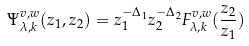Convert formula to latex. <formula><loc_0><loc_0><loc_500><loc_500>\Psi _ { \lambda , k } ^ { v , w } ( z _ { 1 } , z _ { 2 } ) = z _ { 1 } ^ { - \Delta _ { 1 } } z _ { 2 } ^ { - \Delta _ { 2 } } F _ { \lambda , k } ^ { v , w } ( \frac { z _ { 2 } } { z _ { 1 } } )</formula> 